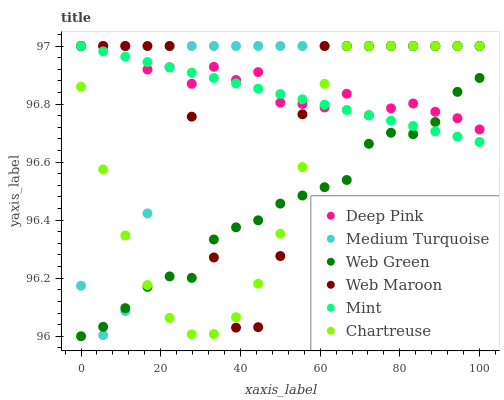Does Web Green have the minimum area under the curve?
Answer yes or no. Yes. Does Deep Pink have the maximum area under the curve?
Answer yes or no. Yes. Does Web Maroon have the minimum area under the curve?
Answer yes or no. No. Does Web Maroon have the maximum area under the curve?
Answer yes or no. No. Is Mint the smoothest?
Answer yes or no. Yes. Is Web Maroon the roughest?
Answer yes or no. Yes. Is Web Green the smoothest?
Answer yes or no. No. Is Web Green the roughest?
Answer yes or no. No. Does Web Green have the lowest value?
Answer yes or no. Yes. Does Web Maroon have the lowest value?
Answer yes or no. No. Does Mint have the highest value?
Answer yes or no. Yes. Does Web Green have the highest value?
Answer yes or no. No. Does Web Green intersect Deep Pink?
Answer yes or no. Yes. Is Web Green less than Deep Pink?
Answer yes or no. No. Is Web Green greater than Deep Pink?
Answer yes or no. No. 